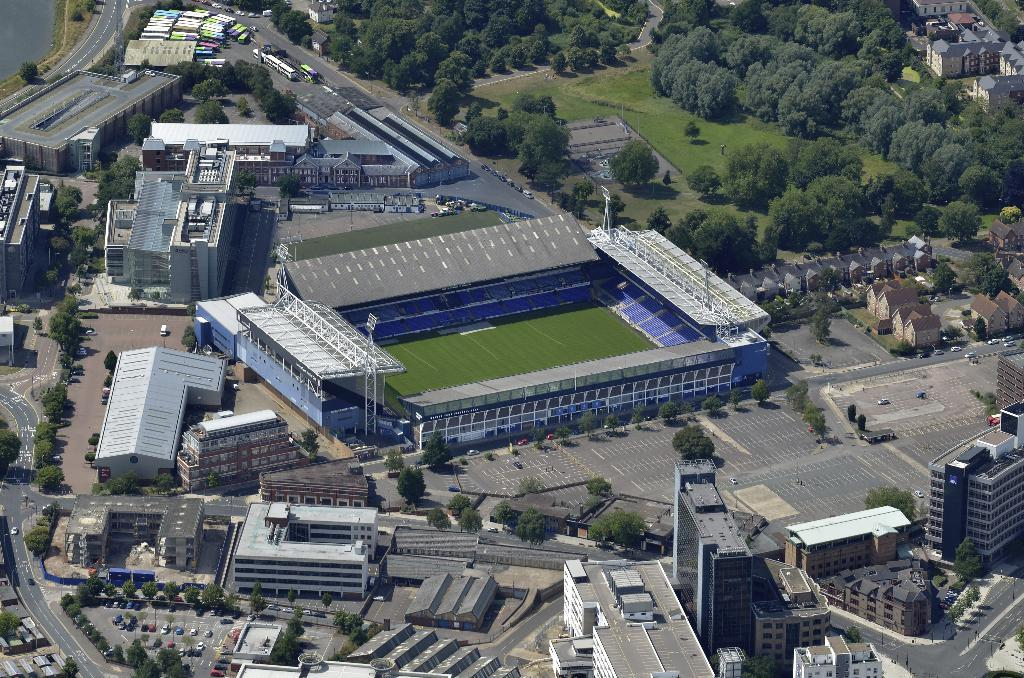What type of structures can be seen in the image? There are many buildings in the image. What else can be seen in the image besides buildings? There are cars and trees visible in the image. What is the main feature in the middle of the image? There appears to be a stadium in the middle of the image. What type of trousers are being worn by the beef in the image? There is no beef or trousers present in the image. Can you describe the taste of the image? The image is a visual representation and does not have a taste. 